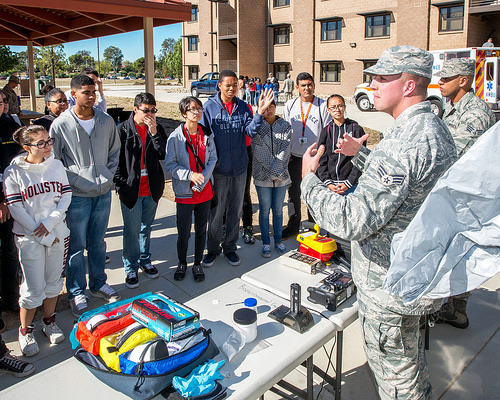<image>
Is the man behind the table? Yes. From this viewpoint, the man is positioned behind the table, with the table partially or fully occluding the man. 